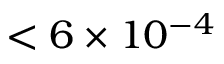Convert formula to latex. <formula><loc_0><loc_0><loc_500><loc_500>< 6 \times 1 0 ^ { - 4 }</formula> 